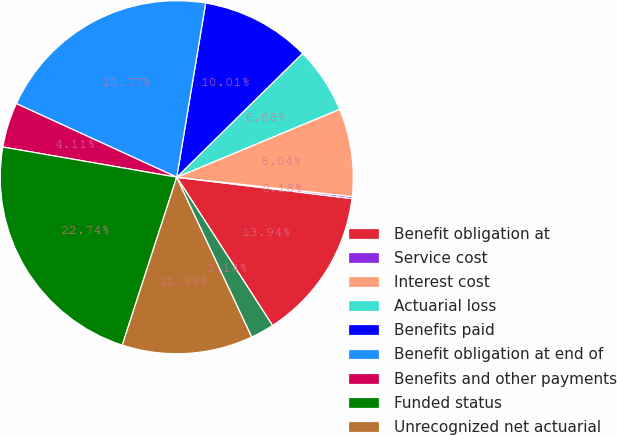Convert chart to OTSL. <chart><loc_0><loc_0><loc_500><loc_500><pie_chart><fcel>Benefit obligation at<fcel>Service cost<fcel>Interest cost<fcel>Actuarial loss<fcel>Benefits paid<fcel>Benefit obligation at end of<fcel>Benefits and other payments<fcel>Funded status<fcel>Unrecognized net actuarial<fcel>Unrecognized prior service<nl><fcel>13.94%<fcel>0.18%<fcel>8.04%<fcel>6.08%<fcel>10.01%<fcel>20.77%<fcel>4.11%<fcel>22.74%<fcel>11.98%<fcel>2.14%<nl></chart> 